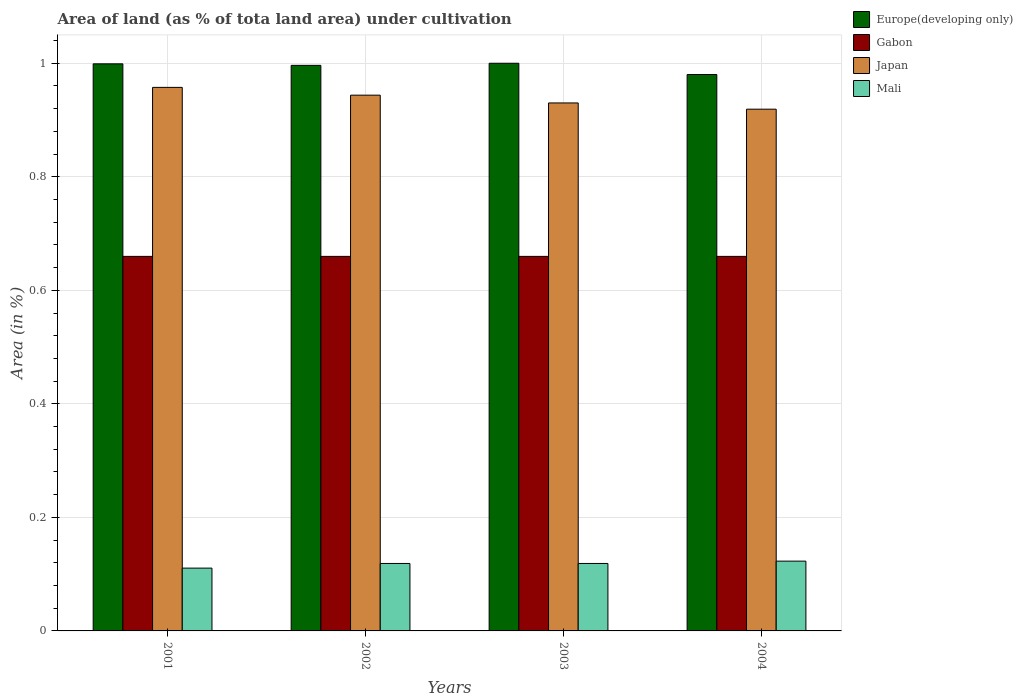How many different coloured bars are there?
Provide a succinct answer. 4. Are the number of bars on each tick of the X-axis equal?
Offer a terse response. Yes. How many bars are there on the 4th tick from the left?
Offer a terse response. 4. How many bars are there on the 3rd tick from the right?
Give a very brief answer. 4. What is the percentage of land under cultivation in Japan in 2002?
Provide a short and direct response. 0.94. Across all years, what is the maximum percentage of land under cultivation in Mali?
Offer a very short reply. 0.12. Across all years, what is the minimum percentage of land under cultivation in Mali?
Provide a succinct answer. 0.11. In which year was the percentage of land under cultivation in Japan maximum?
Offer a very short reply. 2001. What is the total percentage of land under cultivation in Japan in the graph?
Your answer should be very brief. 3.75. What is the difference between the percentage of land under cultivation in Mali in 2002 and that in 2003?
Ensure brevity in your answer.  0. What is the difference between the percentage of land under cultivation in Europe(developing only) in 2003 and the percentage of land under cultivation in Japan in 2001?
Keep it short and to the point. 0.04. What is the average percentage of land under cultivation in Europe(developing only) per year?
Ensure brevity in your answer.  0.99. In the year 2004, what is the difference between the percentage of land under cultivation in Mali and percentage of land under cultivation in Japan?
Your answer should be very brief. -0.8. Is the percentage of land under cultivation in Mali in 2001 less than that in 2003?
Your response must be concise. Yes. Is the difference between the percentage of land under cultivation in Mali in 2002 and 2004 greater than the difference between the percentage of land under cultivation in Japan in 2002 and 2004?
Your response must be concise. No. What is the difference between the highest and the second highest percentage of land under cultivation in Japan?
Make the answer very short. 0.01. What is the difference between the highest and the lowest percentage of land under cultivation in Mali?
Provide a succinct answer. 0.01. What does the 3rd bar from the left in 2003 represents?
Your response must be concise. Japan. What does the 4th bar from the right in 2002 represents?
Offer a terse response. Europe(developing only). Is it the case that in every year, the sum of the percentage of land under cultivation in Japan and percentage of land under cultivation in Mali is greater than the percentage of land under cultivation in Europe(developing only)?
Provide a succinct answer. Yes. How many bars are there?
Offer a very short reply. 16. Does the graph contain any zero values?
Your answer should be very brief. No. How many legend labels are there?
Your response must be concise. 4. How are the legend labels stacked?
Offer a terse response. Vertical. What is the title of the graph?
Make the answer very short. Area of land (as % of tota land area) under cultivation. What is the label or title of the X-axis?
Your response must be concise. Years. What is the label or title of the Y-axis?
Provide a succinct answer. Area (in %). What is the Area (in %) in Europe(developing only) in 2001?
Ensure brevity in your answer.  1. What is the Area (in %) of Gabon in 2001?
Keep it short and to the point. 0.66. What is the Area (in %) of Japan in 2001?
Your answer should be compact. 0.96. What is the Area (in %) in Mali in 2001?
Ensure brevity in your answer.  0.11. What is the Area (in %) of Europe(developing only) in 2002?
Keep it short and to the point. 1. What is the Area (in %) of Gabon in 2002?
Keep it short and to the point. 0.66. What is the Area (in %) of Japan in 2002?
Your answer should be compact. 0.94. What is the Area (in %) of Mali in 2002?
Offer a very short reply. 0.12. What is the Area (in %) in Europe(developing only) in 2003?
Provide a succinct answer. 1. What is the Area (in %) in Gabon in 2003?
Keep it short and to the point. 0.66. What is the Area (in %) of Japan in 2003?
Keep it short and to the point. 0.93. What is the Area (in %) in Mali in 2003?
Ensure brevity in your answer.  0.12. What is the Area (in %) in Europe(developing only) in 2004?
Provide a short and direct response. 0.98. What is the Area (in %) of Gabon in 2004?
Give a very brief answer. 0.66. What is the Area (in %) in Japan in 2004?
Ensure brevity in your answer.  0.92. What is the Area (in %) of Mali in 2004?
Offer a terse response. 0.12. Across all years, what is the maximum Area (in %) of Europe(developing only)?
Keep it short and to the point. 1. Across all years, what is the maximum Area (in %) of Gabon?
Give a very brief answer. 0.66. Across all years, what is the maximum Area (in %) of Japan?
Provide a succinct answer. 0.96. Across all years, what is the maximum Area (in %) in Mali?
Your response must be concise. 0.12. Across all years, what is the minimum Area (in %) in Europe(developing only)?
Your response must be concise. 0.98. Across all years, what is the minimum Area (in %) of Gabon?
Ensure brevity in your answer.  0.66. Across all years, what is the minimum Area (in %) of Japan?
Offer a terse response. 0.92. Across all years, what is the minimum Area (in %) of Mali?
Offer a very short reply. 0.11. What is the total Area (in %) in Europe(developing only) in the graph?
Provide a succinct answer. 3.98. What is the total Area (in %) of Gabon in the graph?
Your answer should be compact. 2.64. What is the total Area (in %) in Japan in the graph?
Provide a succinct answer. 3.75. What is the total Area (in %) of Mali in the graph?
Offer a terse response. 0.47. What is the difference between the Area (in %) of Europe(developing only) in 2001 and that in 2002?
Your answer should be compact. 0. What is the difference between the Area (in %) in Gabon in 2001 and that in 2002?
Your response must be concise. 0. What is the difference between the Area (in %) in Japan in 2001 and that in 2002?
Offer a terse response. 0.01. What is the difference between the Area (in %) of Mali in 2001 and that in 2002?
Offer a very short reply. -0.01. What is the difference between the Area (in %) of Europe(developing only) in 2001 and that in 2003?
Offer a terse response. -0. What is the difference between the Area (in %) of Gabon in 2001 and that in 2003?
Your answer should be compact. 0. What is the difference between the Area (in %) of Japan in 2001 and that in 2003?
Your answer should be very brief. 0.03. What is the difference between the Area (in %) of Mali in 2001 and that in 2003?
Your response must be concise. -0.01. What is the difference between the Area (in %) of Europe(developing only) in 2001 and that in 2004?
Make the answer very short. 0.02. What is the difference between the Area (in %) in Gabon in 2001 and that in 2004?
Give a very brief answer. 0. What is the difference between the Area (in %) in Japan in 2001 and that in 2004?
Offer a very short reply. 0.04. What is the difference between the Area (in %) of Mali in 2001 and that in 2004?
Offer a terse response. -0.01. What is the difference between the Area (in %) of Europe(developing only) in 2002 and that in 2003?
Your answer should be compact. -0. What is the difference between the Area (in %) of Japan in 2002 and that in 2003?
Provide a short and direct response. 0.01. What is the difference between the Area (in %) of Europe(developing only) in 2002 and that in 2004?
Ensure brevity in your answer.  0.02. What is the difference between the Area (in %) in Gabon in 2002 and that in 2004?
Your answer should be very brief. 0. What is the difference between the Area (in %) in Japan in 2002 and that in 2004?
Make the answer very short. 0.02. What is the difference between the Area (in %) of Mali in 2002 and that in 2004?
Offer a very short reply. -0. What is the difference between the Area (in %) of Europe(developing only) in 2003 and that in 2004?
Your answer should be compact. 0.02. What is the difference between the Area (in %) in Japan in 2003 and that in 2004?
Your response must be concise. 0.01. What is the difference between the Area (in %) of Mali in 2003 and that in 2004?
Offer a very short reply. -0. What is the difference between the Area (in %) in Europe(developing only) in 2001 and the Area (in %) in Gabon in 2002?
Your response must be concise. 0.34. What is the difference between the Area (in %) of Europe(developing only) in 2001 and the Area (in %) of Japan in 2002?
Your response must be concise. 0.06. What is the difference between the Area (in %) of Europe(developing only) in 2001 and the Area (in %) of Mali in 2002?
Keep it short and to the point. 0.88. What is the difference between the Area (in %) in Gabon in 2001 and the Area (in %) in Japan in 2002?
Make the answer very short. -0.28. What is the difference between the Area (in %) in Gabon in 2001 and the Area (in %) in Mali in 2002?
Give a very brief answer. 0.54. What is the difference between the Area (in %) of Japan in 2001 and the Area (in %) of Mali in 2002?
Provide a short and direct response. 0.84. What is the difference between the Area (in %) of Europe(developing only) in 2001 and the Area (in %) of Gabon in 2003?
Give a very brief answer. 0.34. What is the difference between the Area (in %) of Europe(developing only) in 2001 and the Area (in %) of Japan in 2003?
Provide a succinct answer. 0.07. What is the difference between the Area (in %) in Europe(developing only) in 2001 and the Area (in %) in Mali in 2003?
Offer a terse response. 0.88. What is the difference between the Area (in %) in Gabon in 2001 and the Area (in %) in Japan in 2003?
Keep it short and to the point. -0.27. What is the difference between the Area (in %) of Gabon in 2001 and the Area (in %) of Mali in 2003?
Your answer should be compact. 0.54. What is the difference between the Area (in %) of Japan in 2001 and the Area (in %) of Mali in 2003?
Your answer should be very brief. 0.84. What is the difference between the Area (in %) in Europe(developing only) in 2001 and the Area (in %) in Gabon in 2004?
Ensure brevity in your answer.  0.34. What is the difference between the Area (in %) of Europe(developing only) in 2001 and the Area (in %) of Japan in 2004?
Your answer should be very brief. 0.08. What is the difference between the Area (in %) of Europe(developing only) in 2001 and the Area (in %) of Mali in 2004?
Your response must be concise. 0.88. What is the difference between the Area (in %) of Gabon in 2001 and the Area (in %) of Japan in 2004?
Make the answer very short. -0.26. What is the difference between the Area (in %) of Gabon in 2001 and the Area (in %) of Mali in 2004?
Keep it short and to the point. 0.54. What is the difference between the Area (in %) of Japan in 2001 and the Area (in %) of Mali in 2004?
Your response must be concise. 0.83. What is the difference between the Area (in %) of Europe(developing only) in 2002 and the Area (in %) of Gabon in 2003?
Offer a terse response. 0.34. What is the difference between the Area (in %) of Europe(developing only) in 2002 and the Area (in %) of Japan in 2003?
Give a very brief answer. 0.07. What is the difference between the Area (in %) in Europe(developing only) in 2002 and the Area (in %) in Mali in 2003?
Your answer should be very brief. 0.88. What is the difference between the Area (in %) in Gabon in 2002 and the Area (in %) in Japan in 2003?
Offer a very short reply. -0.27. What is the difference between the Area (in %) in Gabon in 2002 and the Area (in %) in Mali in 2003?
Provide a succinct answer. 0.54. What is the difference between the Area (in %) of Japan in 2002 and the Area (in %) of Mali in 2003?
Provide a short and direct response. 0.82. What is the difference between the Area (in %) of Europe(developing only) in 2002 and the Area (in %) of Gabon in 2004?
Your answer should be very brief. 0.34. What is the difference between the Area (in %) in Europe(developing only) in 2002 and the Area (in %) in Japan in 2004?
Ensure brevity in your answer.  0.08. What is the difference between the Area (in %) of Europe(developing only) in 2002 and the Area (in %) of Mali in 2004?
Offer a very short reply. 0.87. What is the difference between the Area (in %) of Gabon in 2002 and the Area (in %) of Japan in 2004?
Offer a terse response. -0.26. What is the difference between the Area (in %) of Gabon in 2002 and the Area (in %) of Mali in 2004?
Offer a terse response. 0.54. What is the difference between the Area (in %) of Japan in 2002 and the Area (in %) of Mali in 2004?
Your response must be concise. 0.82. What is the difference between the Area (in %) in Europe(developing only) in 2003 and the Area (in %) in Gabon in 2004?
Provide a short and direct response. 0.34. What is the difference between the Area (in %) of Europe(developing only) in 2003 and the Area (in %) of Japan in 2004?
Offer a very short reply. 0.08. What is the difference between the Area (in %) in Europe(developing only) in 2003 and the Area (in %) in Mali in 2004?
Offer a very short reply. 0.88. What is the difference between the Area (in %) of Gabon in 2003 and the Area (in %) of Japan in 2004?
Make the answer very short. -0.26. What is the difference between the Area (in %) in Gabon in 2003 and the Area (in %) in Mali in 2004?
Give a very brief answer. 0.54. What is the difference between the Area (in %) in Japan in 2003 and the Area (in %) in Mali in 2004?
Keep it short and to the point. 0.81. What is the average Area (in %) in Gabon per year?
Your answer should be compact. 0.66. What is the average Area (in %) of Japan per year?
Offer a terse response. 0.94. What is the average Area (in %) of Mali per year?
Make the answer very short. 0.12. In the year 2001, what is the difference between the Area (in %) in Europe(developing only) and Area (in %) in Gabon?
Your response must be concise. 0.34. In the year 2001, what is the difference between the Area (in %) in Europe(developing only) and Area (in %) in Japan?
Keep it short and to the point. 0.04. In the year 2001, what is the difference between the Area (in %) in Europe(developing only) and Area (in %) in Mali?
Make the answer very short. 0.89. In the year 2001, what is the difference between the Area (in %) of Gabon and Area (in %) of Japan?
Offer a terse response. -0.3. In the year 2001, what is the difference between the Area (in %) of Gabon and Area (in %) of Mali?
Offer a terse response. 0.55. In the year 2001, what is the difference between the Area (in %) in Japan and Area (in %) in Mali?
Keep it short and to the point. 0.85. In the year 2002, what is the difference between the Area (in %) of Europe(developing only) and Area (in %) of Gabon?
Make the answer very short. 0.34. In the year 2002, what is the difference between the Area (in %) in Europe(developing only) and Area (in %) in Japan?
Ensure brevity in your answer.  0.05. In the year 2002, what is the difference between the Area (in %) of Europe(developing only) and Area (in %) of Mali?
Ensure brevity in your answer.  0.88. In the year 2002, what is the difference between the Area (in %) in Gabon and Area (in %) in Japan?
Ensure brevity in your answer.  -0.28. In the year 2002, what is the difference between the Area (in %) of Gabon and Area (in %) of Mali?
Give a very brief answer. 0.54. In the year 2002, what is the difference between the Area (in %) in Japan and Area (in %) in Mali?
Your response must be concise. 0.82. In the year 2003, what is the difference between the Area (in %) of Europe(developing only) and Area (in %) of Gabon?
Give a very brief answer. 0.34. In the year 2003, what is the difference between the Area (in %) in Europe(developing only) and Area (in %) in Japan?
Keep it short and to the point. 0.07. In the year 2003, what is the difference between the Area (in %) of Europe(developing only) and Area (in %) of Mali?
Ensure brevity in your answer.  0.88. In the year 2003, what is the difference between the Area (in %) of Gabon and Area (in %) of Japan?
Your answer should be compact. -0.27. In the year 2003, what is the difference between the Area (in %) in Gabon and Area (in %) in Mali?
Keep it short and to the point. 0.54. In the year 2003, what is the difference between the Area (in %) in Japan and Area (in %) in Mali?
Your response must be concise. 0.81. In the year 2004, what is the difference between the Area (in %) in Europe(developing only) and Area (in %) in Gabon?
Keep it short and to the point. 0.32. In the year 2004, what is the difference between the Area (in %) in Europe(developing only) and Area (in %) in Japan?
Your answer should be very brief. 0.06. In the year 2004, what is the difference between the Area (in %) in Europe(developing only) and Area (in %) in Mali?
Provide a short and direct response. 0.86. In the year 2004, what is the difference between the Area (in %) of Gabon and Area (in %) of Japan?
Give a very brief answer. -0.26. In the year 2004, what is the difference between the Area (in %) in Gabon and Area (in %) in Mali?
Offer a terse response. 0.54. In the year 2004, what is the difference between the Area (in %) of Japan and Area (in %) of Mali?
Your answer should be very brief. 0.8. What is the ratio of the Area (in %) in Europe(developing only) in 2001 to that in 2002?
Ensure brevity in your answer.  1. What is the ratio of the Area (in %) in Japan in 2001 to that in 2002?
Offer a very short reply. 1.01. What is the ratio of the Area (in %) in Gabon in 2001 to that in 2003?
Ensure brevity in your answer.  1. What is the ratio of the Area (in %) of Japan in 2001 to that in 2003?
Offer a terse response. 1.03. What is the ratio of the Area (in %) of Mali in 2001 to that in 2003?
Provide a short and direct response. 0.93. What is the ratio of the Area (in %) of Europe(developing only) in 2001 to that in 2004?
Your response must be concise. 1.02. What is the ratio of the Area (in %) of Japan in 2001 to that in 2004?
Offer a very short reply. 1.04. What is the ratio of the Area (in %) of Mali in 2001 to that in 2004?
Offer a terse response. 0.9. What is the ratio of the Area (in %) of Europe(developing only) in 2002 to that in 2003?
Ensure brevity in your answer.  1. What is the ratio of the Area (in %) in Gabon in 2002 to that in 2003?
Provide a short and direct response. 1. What is the ratio of the Area (in %) in Japan in 2002 to that in 2003?
Provide a succinct answer. 1.01. What is the ratio of the Area (in %) of Mali in 2002 to that in 2003?
Provide a succinct answer. 1. What is the ratio of the Area (in %) of Europe(developing only) in 2002 to that in 2004?
Your response must be concise. 1.02. What is the ratio of the Area (in %) in Gabon in 2002 to that in 2004?
Make the answer very short. 1. What is the ratio of the Area (in %) in Japan in 2002 to that in 2004?
Give a very brief answer. 1.03. What is the ratio of the Area (in %) of Mali in 2002 to that in 2004?
Offer a terse response. 0.97. What is the ratio of the Area (in %) in Europe(developing only) in 2003 to that in 2004?
Offer a terse response. 1.02. What is the ratio of the Area (in %) in Gabon in 2003 to that in 2004?
Ensure brevity in your answer.  1. What is the ratio of the Area (in %) in Japan in 2003 to that in 2004?
Your response must be concise. 1.01. What is the ratio of the Area (in %) in Mali in 2003 to that in 2004?
Your answer should be compact. 0.97. What is the difference between the highest and the second highest Area (in %) of Europe(developing only)?
Make the answer very short. 0. What is the difference between the highest and the second highest Area (in %) of Japan?
Provide a short and direct response. 0.01. What is the difference between the highest and the second highest Area (in %) in Mali?
Provide a succinct answer. 0. What is the difference between the highest and the lowest Area (in %) in Europe(developing only)?
Make the answer very short. 0.02. What is the difference between the highest and the lowest Area (in %) of Gabon?
Keep it short and to the point. 0. What is the difference between the highest and the lowest Area (in %) in Japan?
Make the answer very short. 0.04. What is the difference between the highest and the lowest Area (in %) of Mali?
Keep it short and to the point. 0.01. 